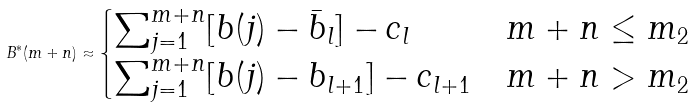Convert formula to latex. <formula><loc_0><loc_0><loc_500><loc_500>B ^ { * } ( m + n ) \approx \begin{cases} \sum _ { j = 1 } ^ { m + n } [ b ( j ) - { \bar { b } } _ { l } ] - c _ { l } & m + n \leq m _ { 2 } \\ \sum _ { j = 1 } ^ { m + n } [ b ( j ) - b _ { l + 1 } ] - c _ { l + 1 } & m + n > m _ { 2 } \end{cases}</formula> 